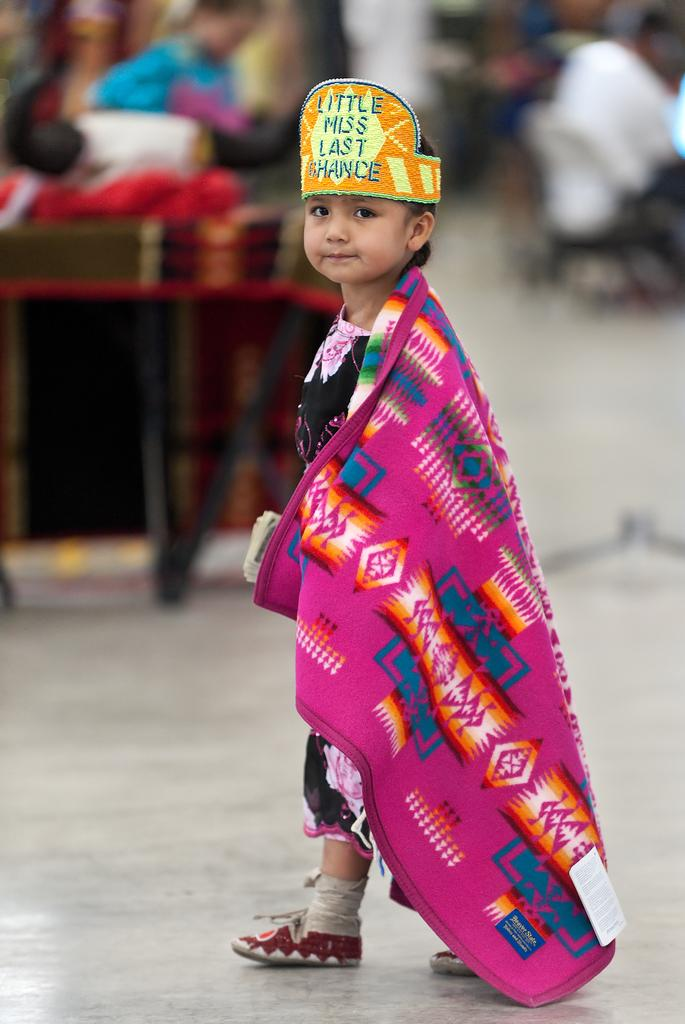Who is the main subject in the image? There is a boy in the image. What is the boy wearing on his head? The boy is wearing a crown. Can you describe the background of the image? There are people in the background of the image. What is visible at the bottom of the image? There is a floor visible at the bottom of the image. How many children are crying in the image? There are no children crying in the image; it only features a boy wearing a crown. 